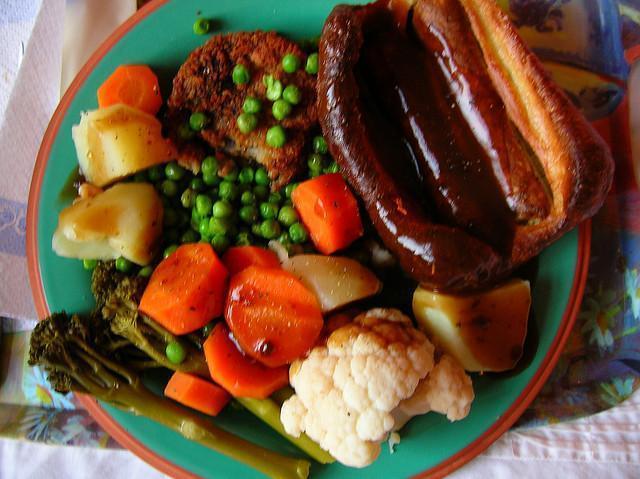How many carrots are there?
Give a very brief answer. 5. How many broccolis are in the photo?
Give a very brief answer. 2. How many oxygen tubes is the man in the bed wearing?
Give a very brief answer. 0. 